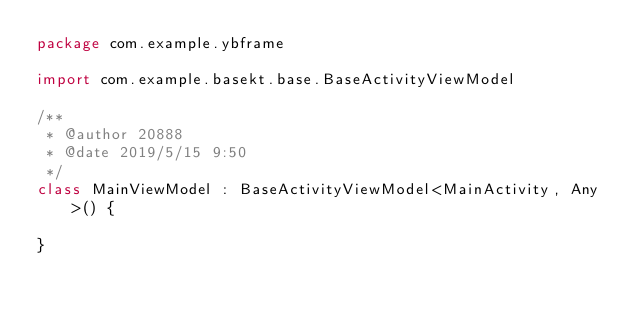Convert code to text. <code><loc_0><loc_0><loc_500><loc_500><_Kotlin_>package com.example.ybframe

import com.example.basekt.base.BaseActivityViewModel

/**
 * @author 20888
 * @date 2019/5/15 9:50
 */
class MainViewModel : BaseActivityViewModel<MainActivity, Any>() {

}</code> 